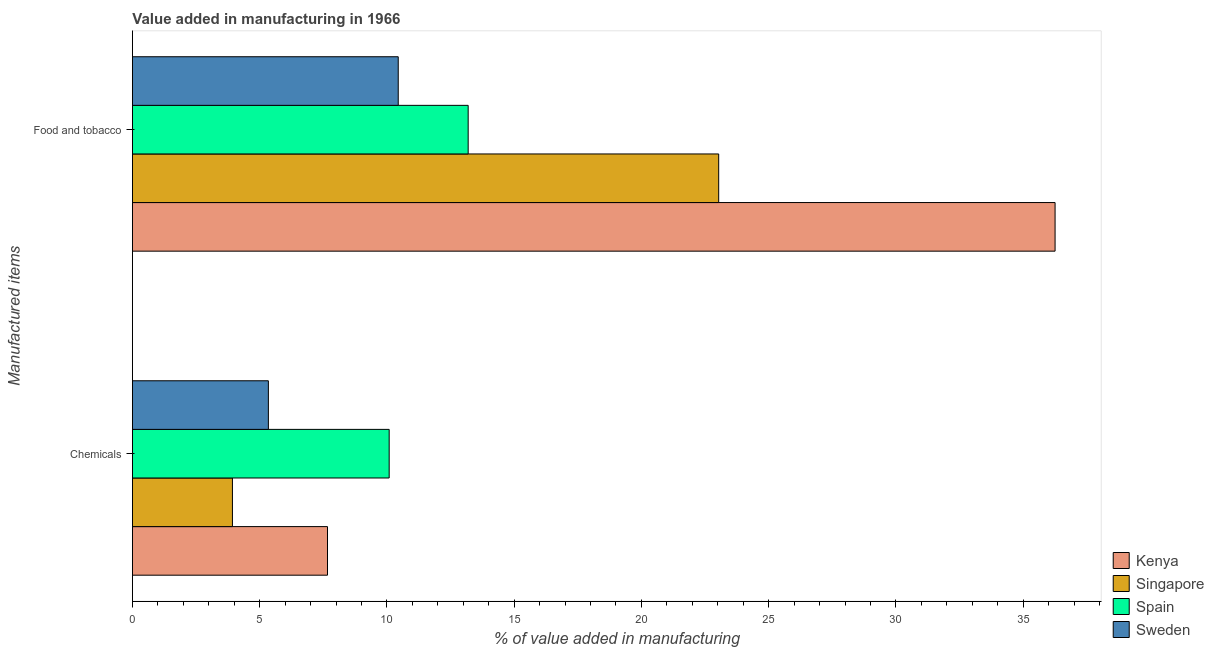Are the number of bars on each tick of the Y-axis equal?
Offer a very short reply. Yes. How many bars are there on the 1st tick from the bottom?
Make the answer very short. 4. What is the label of the 1st group of bars from the top?
Offer a very short reply. Food and tobacco. What is the value added by  manufacturing chemicals in Kenya?
Your response must be concise. 7.67. Across all countries, what is the maximum value added by manufacturing food and tobacco?
Make the answer very short. 36.25. Across all countries, what is the minimum value added by manufacturing food and tobacco?
Keep it short and to the point. 10.44. In which country was the value added by  manufacturing chemicals maximum?
Give a very brief answer. Spain. In which country was the value added by  manufacturing chemicals minimum?
Your answer should be very brief. Singapore. What is the total value added by manufacturing food and tobacco in the graph?
Provide a succinct answer. 82.93. What is the difference between the value added by  manufacturing chemicals in Singapore and that in Sweden?
Your answer should be compact. -1.41. What is the difference between the value added by manufacturing food and tobacco in Sweden and the value added by  manufacturing chemicals in Singapore?
Make the answer very short. 6.51. What is the average value added by  manufacturing chemicals per country?
Ensure brevity in your answer.  6.76. What is the difference between the value added by  manufacturing chemicals and value added by manufacturing food and tobacco in Sweden?
Provide a short and direct response. -5.1. What is the ratio of the value added by  manufacturing chemicals in Kenya to that in Singapore?
Your answer should be very brief. 1.95. Is the value added by  manufacturing chemicals in Singapore less than that in Sweden?
Provide a succinct answer. Yes. What does the 1st bar from the top in Food and tobacco represents?
Ensure brevity in your answer.  Sweden. What does the 4th bar from the bottom in Chemicals represents?
Your response must be concise. Sweden. How many bars are there?
Make the answer very short. 8. How many countries are there in the graph?
Ensure brevity in your answer.  4. What is the difference between two consecutive major ticks on the X-axis?
Your answer should be very brief. 5. Are the values on the major ticks of X-axis written in scientific E-notation?
Give a very brief answer. No. Does the graph contain any zero values?
Make the answer very short. No. Where does the legend appear in the graph?
Provide a succinct answer. Bottom right. What is the title of the graph?
Your response must be concise. Value added in manufacturing in 1966. Does "Barbados" appear as one of the legend labels in the graph?
Offer a terse response. No. What is the label or title of the X-axis?
Offer a very short reply. % of value added in manufacturing. What is the label or title of the Y-axis?
Provide a short and direct response. Manufactured items. What is the % of value added in manufacturing of Kenya in Chemicals?
Provide a short and direct response. 7.67. What is the % of value added in manufacturing in Singapore in Chemicals?
Provide a succinct answer. 3.93. What is the % of value added in manufacturing in Spain in Chemicals?
Your answer should be compact. 10.09. What is the % of value added in manufacturing in Sweden in Chemicals?
Ensure brevity in your answer.  5.34. What is the % of value added in manufacturing of Kenya in Food and tobacco?
Keep it short and to the point. 36.25. What is the % of value added in manufacturing in Singapore in Food and tobacco?
Offer a very short reply. 23.04. What is the % of value added in manufacturing of Spain in Food and tobacco?
Provide a short and direct response. 13.19. What is the % of value added in manufacturing in Sweden in Food and tobacco?
Provide a short and direct response. 10.44. Across all Manufactured items, what is the maximum % of value added in manufacturing in Kenya?
Make the answer very short. 36.25. Across all Manufactured items, what is the maximum % of value added in manufacturing in Singapore?
Provide a short and direct response. 23.04. Across all Manufactured items, what is the maximum % of value added in manufacturing of Spain?
Your answer should be compact. 13.19. Across all Manufactured items, what is the maximum % of value added in manufacturing of Sweden?
Your answer should be very brief. 10.44. Across all Manufactured items, what is the minimum % of value added in manufacturing of Kenya?
Offer a very short reply. 7.67. Across all Manufactured items, what is the minimum % of value added in manufacturing in Singapore?
Ensure brevity in your answer.  3.93. Across all Manufactured items, what is the minimum % of value added in manufacturing in Spain?
Give a very brief answer. 10.09. Across all Manufactured items, what is the minimum % of value added in manufacturing of Sweden?
Make the answer very short. 5.34. What is the total % of value added in manufacturing in Kenya in the graph?
Keep it short and to the point. 43.92. What is the total % of value added in manufacturing of Singapore in the graph?
Ensure brevity in your answer.  26.97. What is the total % of value added in manufacturing of Spain in the graph?
Ensure brevity in your answer.  23.28. What is the total % of value added in manufacturing of Sweden in the graph?
Your answer should be very brief. 15.79. What is the difference between the % of value added in manufacturing of Kenya in Chemicals and that in Food and tobacco?
Offer a terse response. -28.59. What is the difference between the % of value added in manufacturing of Singapore in Chemicals and that in Food and tobacco?
Ensure brevity in your answer.  -19.11. What is the difference between the % of value added in manufacturing in Spain in Chemicals and that in Food and tobacco?
Provide a succinct answer. -3.1. What is the difference between the % of value added in manufacturing of Sweden in Chemicals and that in Food and tobacco?
Make the answer very short. -5.1. What is the difference between the % of value added in manufacturing of Kenya in Chemicals and the % of value added in manufacturing of Singapore in Food and tobacco?
Provide a succinct answer. -15.37. What is the difference between the % of value added in manufacturing of Kenya in Chemicals and the % of value added in manufacturing of Spain in Food and tobacco?
Ensure brevity in your answer.  -5.53. What is the difference between the % of value added in manufacturing of Kenya in Chemicals and the % of value added in manufacturing of Sweden in Food and tobacco?
Offer a terse response. -2.78. What is the difference between the % of value added in manufacturing in Singapore in Chemicals and the % of value added in manufacturing in Spain in Food and tobacco?
Offer a very short reply. -9.26. What is the difference between the % of value added in manufacturing in Singapore in Chemicals and the % of value added in manufacturing in Sweden in Food and tobacco?
Your answer should be very brief. -6.51. What is the difference between the % of value added in manufacturing of Spain in Chemicals and the % of value added in manufacturing of Sweden in Food and tobacco?
Keep it short and to the point. -0.36. What is the average % of value added in manufacturing in Kenya per Manufactured items?
Give a very brief answer. 21.96. What is the average % of value added in manufacturing in Singapore per Manufactured items?
Make the answer very short. 13.48. What is the average % of value added in manufacturing in Spain per Manufactured items?
Provide a short and direct response. 11.64. What is the average % of value added in manufacturing in Sweden per Manufactured items?
Offer a very short reply. 7.89. What is the difference between the % of value added in manufacturing in Kenya and % of value added in manufacturing in Singapore in Chemicals?
Your answer should be very brief. 3.74. What is the difference between the % of value added in manufacturing in Kenya and % of value added in manufacturing in Spain in Chemicals?
Keep it short and to the point. -2.42. What is the difference between the % of value added in manufacturing in Kenya and % of value added in manufacturing in Sweden in Chemicals?
Your response must be concise. 2.32. What is the difference between the % of value added in manufacturing in Singapore and % of value added in manufacturing in Spain in Chemicals?
Provide a succinct answer. -6.16. What is the difference between the % of value added in manufacturing of Singapore and % of value added in manufacturing of Sweden in Chemicals?
Ensure brevity in your answer.  -1.41. What is the difference between the % of value added in manufacturing in Spain and % of value added in manufacturing in Sweden in Chemicals?
Make the answer very short. 4.75. What is the difference between the % of value added in manufacturing of Kenya and % of value added in manufacturing of Singapore in Food and tobacco?
Offer a very short reply. 13.22. What is the difference between the % of value added in manufacturing in Kenya and % of value added in manufacturing in Spain in Food and tobacco?
Provide a short and direct response. 23.06. What is the difference between the % of value added in manufacturing in Kenya and % of value added in manufacturing in Sweden in Food and tobacco?
Make the answer very short. 25.81. What is the difference between the % of value added in manufacturing of Singapore and % of value added in manufacturing of Spain in Food and tobacco?
Keep it short and to the point. 9.84. What is the difference between the % of value added in manufacturing in Singapore and % of value added in manufacturing in Sweden in Food and tobacco?
Make the answer very short. 12.59. What is the difference between the % of value added in manufacturing of Spain and % of value added in manufacturing of Sweden in Food and tobacco?
Make the answer very short. 2.75. What is the ratio of the % of value added in manufacturing in Kenya in Chemicals to that in Food and tobacco?
Provide a succinct answer. 0.21. What is the ratio of the % of value added in manufacturing of Singapore in Chemicals to that in Food and tobacco?
Provide a succinct answer. 0.17. What is the ratio of the % of value added in manufacturing of Spain in Chemicals to that in Food and tobacco?
Provide a succinct answer. 0.76. What is the ratio of the % of value added in manufacturing of Sweden in Chemicals to that in Food and tobacco?
Offer a terse response. 0.51. What is the difference between the highest and the second highest % of value added in manufacturing in Kenya?
Offer a terse response. 28.59. What is the difference between the highest and the second highest % of value added in manufacturing in Singapore?
Offer a terse response. 19.11. What is the difference between the highest and the second highest % of value added in manufacturing in Spain?
Offer a terse response. 3.1. What is the difference between the highest and the second highest % of value added in manufacturing in Sweden?
Give a very brief answer. 5.1. What is the difference between the highest and the lowest % of value added in manufacturing in Kenya?
Your response must be concise. 28.59. What is the difference between the highest and the lowest % of value added in manufacturing in Singapore?
Offer a terse response. 19.11. What is the difference between the highest and the lowest % of value added in manufacturing in Spain?
Provide a succinct answer. 3.1. What is the difference between the highest and the lowest % of value added in manufacturing of Sweden?
Make the answer very short. 5.1. 